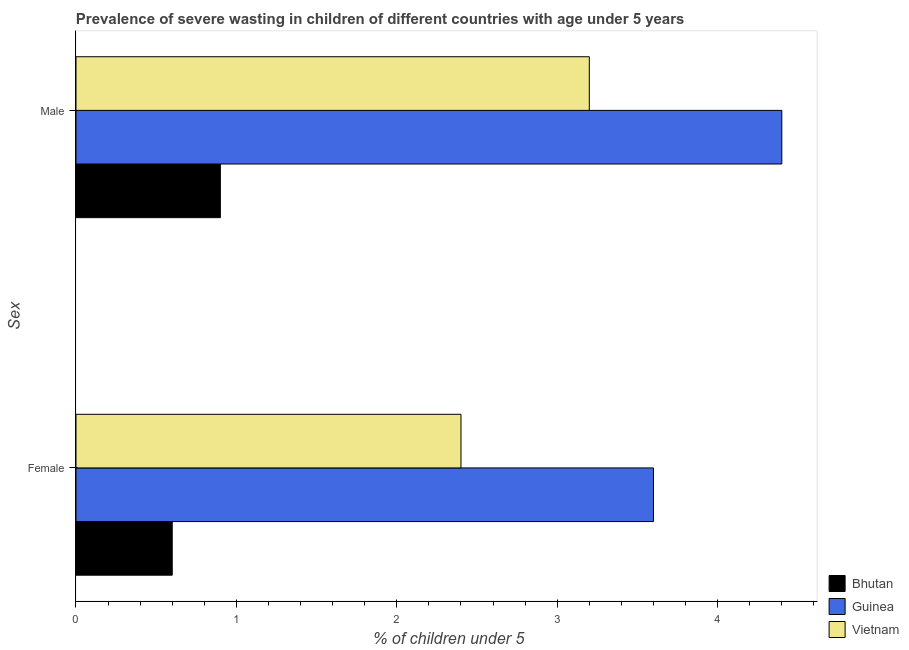How many different coloured bars are there?
Ensure brevity in your answer.  3. Are the number of bars per tick equal to the number of legend labels?
Provide a succinct answer. Yes. How many bars are there on the 2nd tick from the top?
Your response must be concise. 3. How many bars are there on the 1st tick from the bottom?
Give a very brief answer. 3. What is the percentage of undernourished female children in Bhutan?
Your answer should be very brief. 0.6. Across all countries, what is the maximum percentage of undernourished female children?
Your response must be concise. 3.6. Across all countries, what is the minimum percentage of undernourished female children?
Your answer should be compact. 0.6. In which country was the percentage of undernourished male children maximum?
Your response must be concise. Guinea. In which country was the percentage of undernourished male children minimum?
Give a very brief answer. Bhutan. What is the total percentage of undernourished female children in the graph?
Offer a very short reply. 6.6. What is the difference between the percentage of undernourished male children in Guinea and that in Bhutan?
Provide a short and direct response. 3.5. What is the difference between the percentage of undernourished female children in Bhutan and the percentage of undernourished male children in Vietnam?
Keep it short and to the point. -2.6. What is the average percentage of undernourished female children per country?
Offer a terse response. 2.2. What is the difference between the percentage of undernourished male children and percentage of undernourished female children in Bhutan?
Offer a very short reply. 0.3. What is the ratio of the percentage of undernourished female children in Guinea to that in Vietnam?
Offer a terse response. 1.5. Is the percentage of undernourished female children in Vietnam less than that in Guinea?
Make the answer very short. Yes. What does the 2nd bar from the top in Male represents?
Your answer should be very brief. Guinea. What does the 2nd bar from the bottom in Male represents?
Offer a very short reply. Guinea. Are the values on the major ticks of X-axis written in scientific E-notation?
Make the answer very short. No. Where does the legend appear in the graph?
Ensure brevity in your answer.  Bottom right. What is the title of the graph?
Offer a terse response. Prevalence of severe wasting in children of different countries with age under 5 years. Does "Curacao" appear as one of the legend labels in the graph?
Ensure brevity in your answer.  No. What is the label or title of the X-axis?
Offer a terse response.  % of children under 5. What is the label or title of the Y-axis?
Offer a very short reply. Sex. What is the  % of children under 5 in Bhutan in Female?
Provide a short and direct response. 0.6. What is the  % of children under 5 in Guinea in Female?
Offer a terse response. 3.6. What is the  % of children under 5 in Vietnam in Female?
Ensure brevity in your answer.  2.4. What is the  % of children under 5 of Bhutan in Male?
Your answer should be very brief. 0.9. What is the  % of children under 5 in Guinea in Male?
Offer a terse response. 4.4. What is the  % of children under 5 in Vietnam in Male?
Give a very brief answer. 3.2. Across all Sex, what is the maximum  % of children under 5 of Bhutan?
Offer a terse response. 0.9. Across all Sex, what is the maximum  % of children under 5 of Guinea?
Your answer should be very brief. 4.4. Across all Sex, what is the maximum  % of children under 5 of Vietnam?
Your answer should be very brief. 3.2. Across all Sex, what is the minimum  % of children under 5 of Bhutan?
Offer a terse response. 0.6. Across all Sex, what is the minimum  % of children under 5 in Guinea?
Your answer should be very brief. 3.6. Across all Sex, what is the minimum  % of children under 5 of Vietnam?
Provide a succinct answer. 2.4. What is the total  % of children under 5 in Vietnam in the graph?
Ensure brevity in your answer.  5.6. What is the difference between the  % of children under 5 of Guinea in Female and that in Male?
Provide a short and direct response. -0.8. What is the difference between the  % of children under 5 of Bhutan in Female and the  % of children under 5 of Guinea in Male?
Offer a very short reply. -3.8. What is the average  % of children under 5 in Vietnam per Sex?
Offer a terse response. 2.8. What is the difference between the  % of children under 5 in Bhutan and  % of children under 5 in Guinea in Female?
Your answer should be very brief. -3. What is the difference between the  % of children under 5 in Bhutan and  % of children under 5 in Vietnam in Female?
Offer a terse response. -1.8. What is the difference between the  % of children under 5 of Guinea and  % of children under 5 of Vietnam in Female?
Keep it short and to the point. 1.2. What is the difference between the  % of children under 5 of Guinea and  % of children under 5 of Vietnam in Male?
Give a very brief answer. 1.2. What is the ratio of the  % of children under 5 of Guinea in Female to that in Male?
Your answer should be compact. 0.82. What is the difference between the highest and the second highest  % of children under 5 in Vietnam?
Your response must be concise. 0.8. What is the difference between the highest and the lowest  % of children under 5 of Guinea?
Provide a succinct answer. 0.8. 